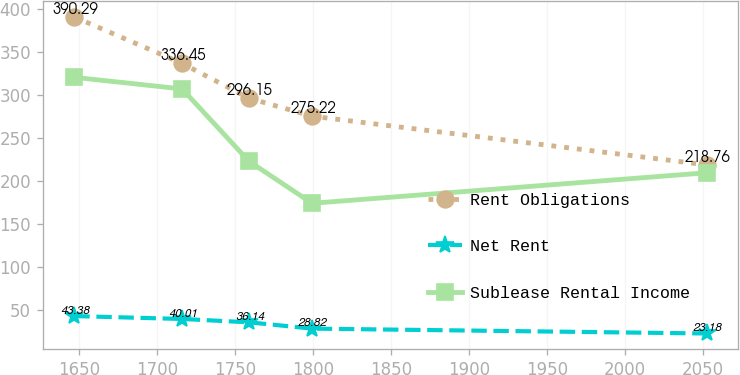Convert chart to OTSL. <chart><loc_0><loc_0><loc_500><loc_500><line_chart><ecel><fcel>Rent Obligations<fcel>Net Rent<fcel>Sublease Rental Income<nl><fcel>1647.09<fcel>390.29<fcel>43.38<fcel>320.3<nl><fcel>1716.19<fcel>336.45<fcel>40.01<fcel>306.83<nl><fcel>1758.91<fcel>296.15<fcel>36.14<fcel>223.07<nl><fcel>1799.41<fcel>275.22<fcel>28.82<fcel>174.19<nl><fcel>2052.09<fcel>218.76<fcel>23.18<fcel>209.6<nl></chart> 